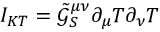Convert formula to latex. <formula><loc_0><loc_0><loc_500><loc_500>I _ { K T } = \tilde { \mathcal { G } } _ { S } ^ { \mu \nu } \partial _ { \mu } T \partial _ { \nu } T</formula> 